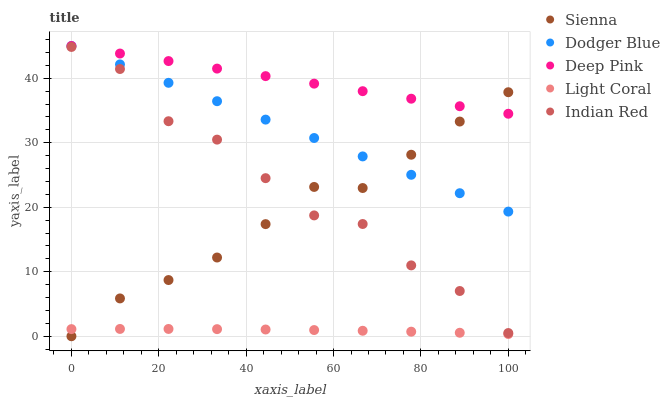Does Light Coral have the minimum area under the curve?
Answer yes or no. Yes. Does Deep Pink have the maximum area under the curve?
Answer yes or no. Yes. Does Deep Pink have the minimum area under the curve?
Answer yes or no. No. Does Light Coral have the maximum area under the curve?
Answer yes or no. No. Is Deep Pink the smoothest?
Answer yes or no. Yes. Is Indian Red the roughest?
Answer yes or no. Yes. Is Light Coral the smoothest?
Answer yes or no. No. Is Light Coral the roughest?
Answer yes or no. No. Does Sienna have the lowest value?
Answer yes or no. Yes. Does Light Coral have the lowest value?
Answer yes or no. No. Does Dodger Blue have the highest value?
Answer yes or no. Yes. Does Light Coral have the highest value?
Answer yes or no. No. Is Indian Red less than Deep Pink?
Answer yes or no. Yes. Is Dodger Blue greater than Light Coral?
Answer yes or no. Yes. Does Sienna intersect Deep Pink?
Answer yes or no. Yes. Is Sienna less than Deep Pink?
Answer yes or no. No. Is Sienna greater than Deep Pink?
Answer yes or no. No. Does Indian Red intersect Deep Pink?
Answer yes or no. No. 